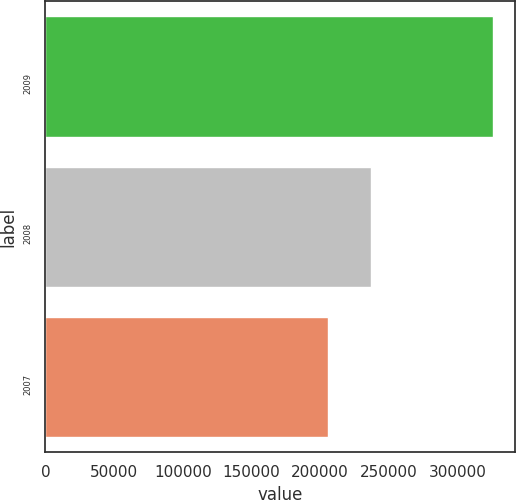Convert chart to OTSL. <chart><loc_0><loc_0><loc_500><loc_500><bar_chart><fcel>2009<fcel>2008<fcel>2007<nl><fcel>325633<fcel>236956<fcel>205688<nl></chart> 